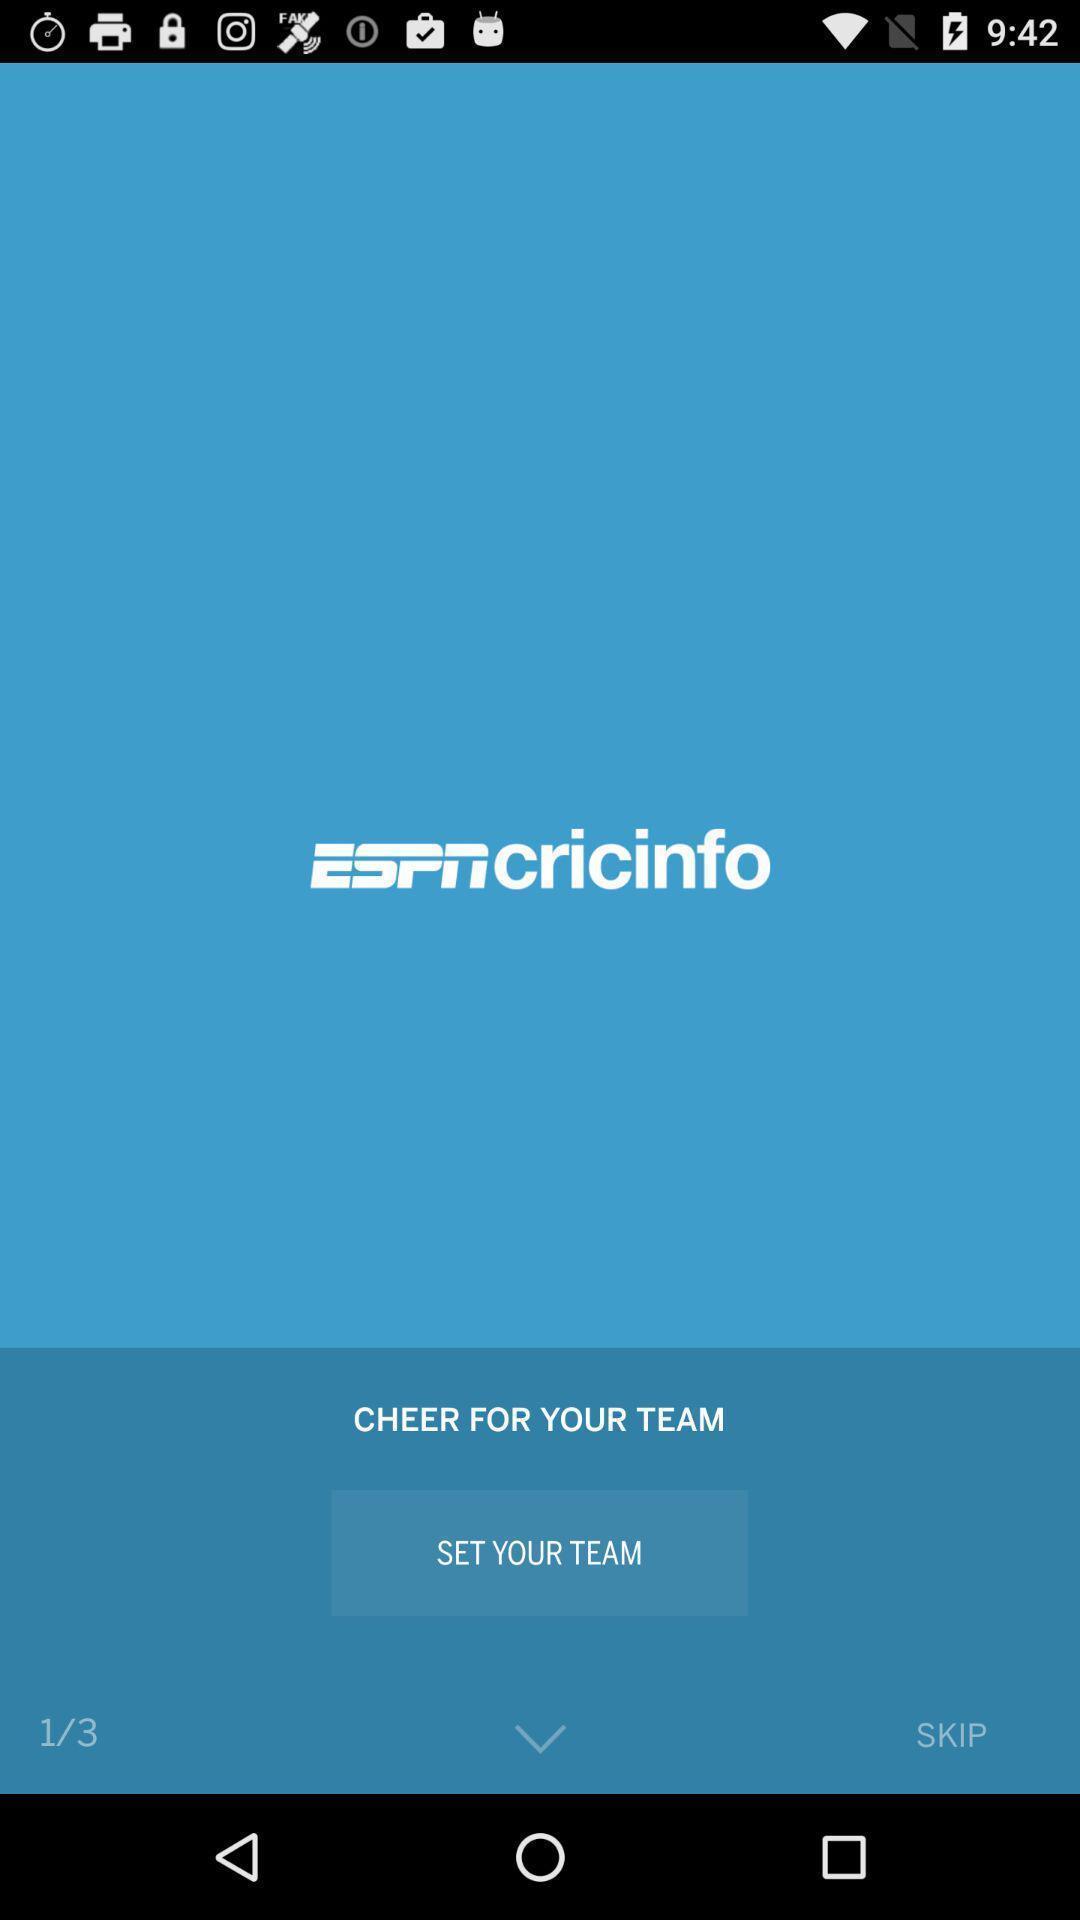What details can you identify in this image? Screen displaying the welcome page of broadcast channel app. 